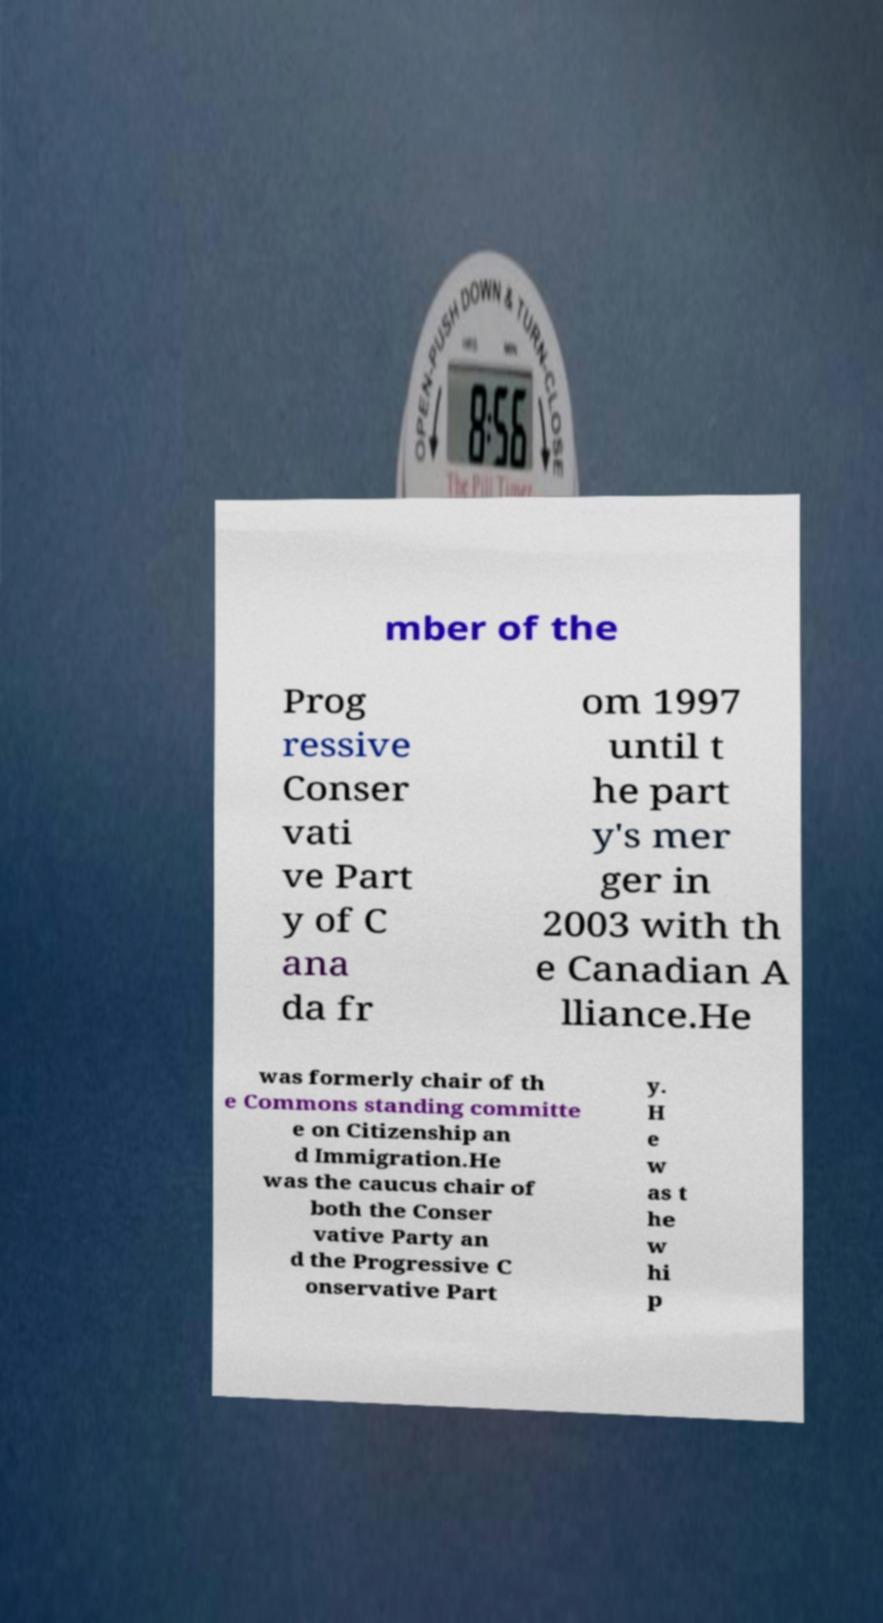Could you assist in decoding the text presented in this image and type it out clearly? mber of the Prog ressive Conser vati ve Part y of C ana da fr om 1997 until t he part y's mer ger in 2003 with th e Canadian A lliance.He was formerly chair of th e Commons standing committe e on Citizenship an d Immigration.He was the caucus chair of both the Conser vative Party an d the Progressive C onservative Part y. H e w as t he w hi p 